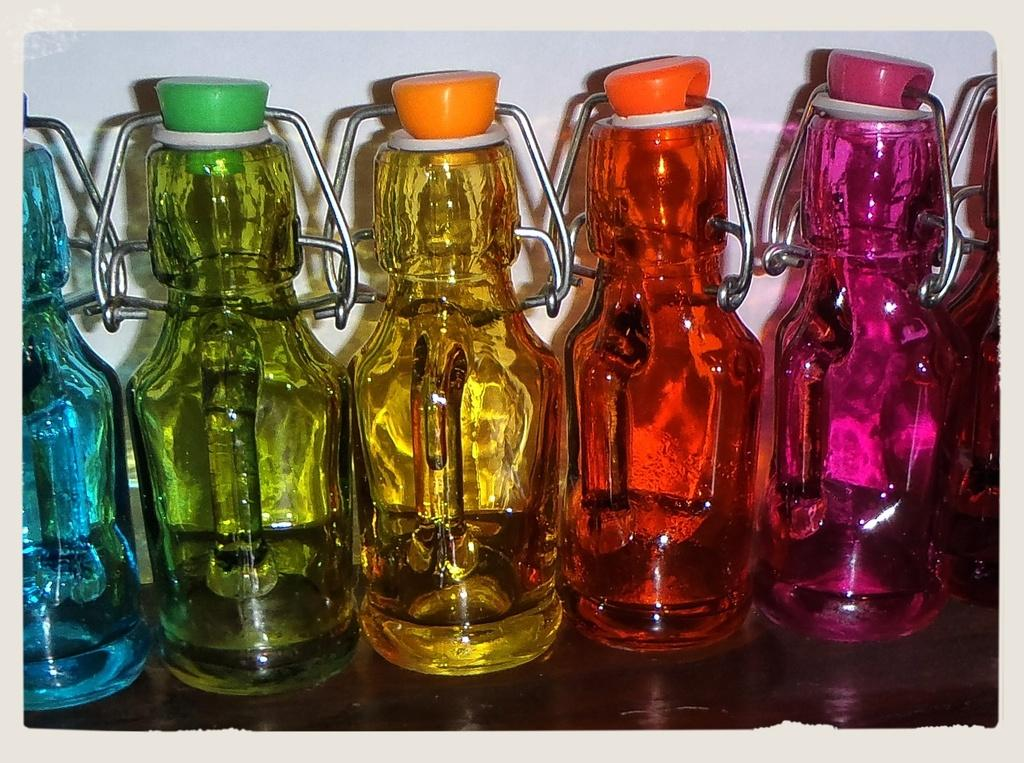What objects are on the table in the image? There are bottles on the table in the image. Can you describe the bottles in more detail? The bottles are in different colors. What is visible behind the bottles in the image? There is a wall behind the bottles in the image. How many snails can be seen crawling on the wall behind the bottles in the image? There are no snails visible in the image; only the bottles and the wall are present. 